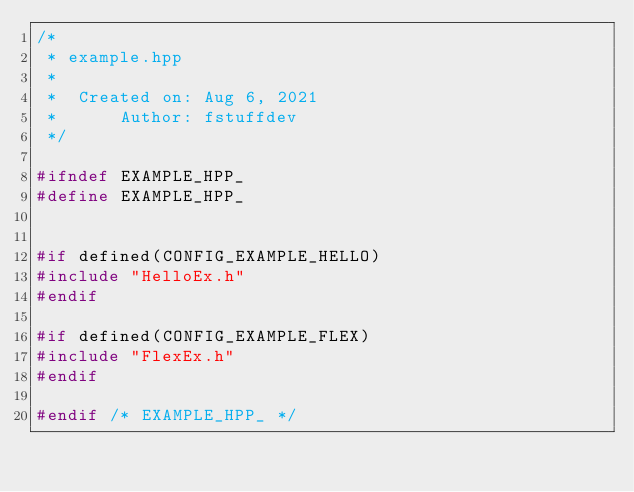Convert code to text. <code><loc_0><loc_0><loc_500><loc_500><_C++_>/*
 * example.hpp
 *
 *  Created on: Aug 6, 2021
 *      Author: fstuffdev
 */

#ifndef EXAMPLE_HPP_
#define EXAMPLE_HPP_


#if defined(CONFIG_EXAMPLE_HELLO)
#include "HelloEx.h"
#endif

#if defined(CONFIG_EXAMPLE_FLEX)
#include "FlexEx.h"
#endif

#endif /* EXAMPLE_HPP_ */
</code> 